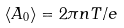Convert formula to latex. <formula><loc_0><loc_0><loc_500><loc_500>\langle A _ { 0 } \rangle = 2 \pi n T / e</formula> 